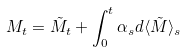Convert formula to latex. <formula><loc_0><loc_0><loc_500><loc_500>M _ { t } = \tilde { M } _ { t } + \int _ { 0 } ^ { t } \alpha _ { s } d \langle \tilde { M } \rangle _ { s }</formula> 